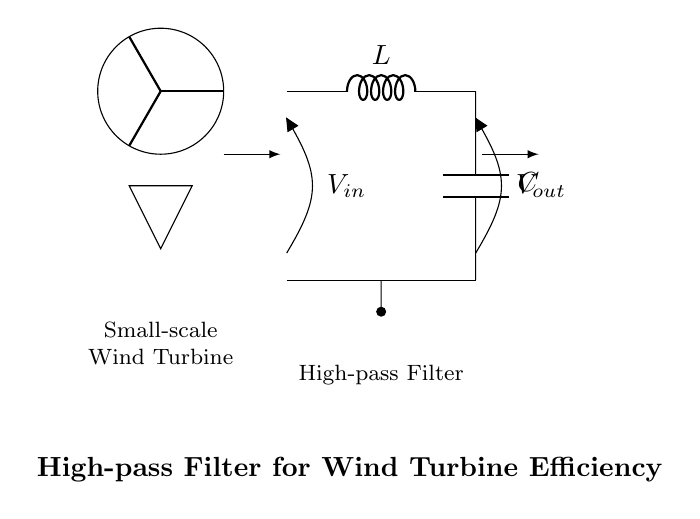What components are used in the high-pass filter? The circuit includes an inductor (L) and a capacitor (C) as the primary components of the high-pass filter. These are essential for determining the filter's operational characteristics.
Answer: Inductor and capacitor What is represented by the symbol at the left of the circuit? The symbol is a representation of a small-scale wind turbine. It indicates that the circuit is intended for use with wind turbine systems.
Answer: Small-scale wind turbine What is the purpose of the high-pass filter in this circuit? The high-pass filter is designed to allow high-frequency signals to pass while blocking lower frequency ones, enhancing the system’s efficiency by filtering unwanted noise.
Answer: Improve efficiency What is the input voltage labeled in the circuit? The input voltage (V_in) is labeled at the top left of the circuit, indicating the voltage supplied to the high-pass filter from the wind turbine.
Answer: V_in What does the output voltage signify in the circuit diagram? The output voltage (V_out) is labeled at the top right of the circuit, representing the voltage that is passed through the high-pass filter after processing the input signal.
Answer: V_out What is the signal flow direction indicated by the arrows? The arrows indicate the direction of signal flow, showing that the signal enters from the left (input) and exits on the right (output) after passing through the filter components.
Answer: Left to right What type of filter is represented in this circuit? The circuit diagram explicitly represents a high-pass filter, which is characterized by its ability to eliminate low-frequency signals while allowing high-frequency signals to pass through.
Answer: High-pass filter 